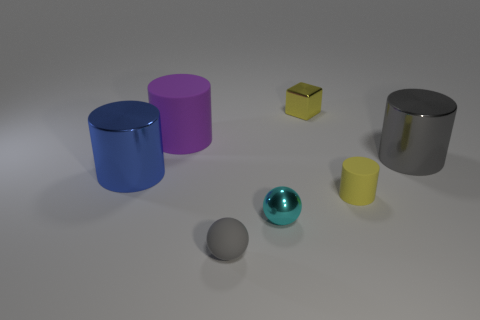There is a yellow matte object; is its shape the same as the gray object that is behind the tiny cyan shiny sphere? Yes, the yellow matte object has the shape of a cube, similar to the gray object located behind the tiny cyan shiny sphere, which is also cube-shaped. Despite differences in size and surface material, their geometric properties are identical. 